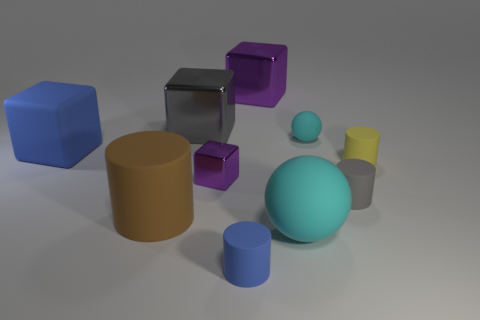There is a small gray cylinder in front of the cyan sphere that is behind the rubber cube behind the tiny purple metallic object; what is its material?
Make the answer very short. Rubber. Are there any cyan things that have the same size as the brown rubber cylinder?
Keep it short and to the point. Yes. The gray thing that is the same material as the big cyan sphere is what size?
Ensure brevity in your answer.  Small. There is a small cyan matte thing; what shape is it?
Provide a short and direct response. Sphere. Is the material of the small purple cube the same as the sphere in front of the gray rubber cylinder?
Offer a very short reply. No. What number of things are gray matte objects or purple things?
Your answer should be very brief. 3. Are there any big cylinders?
Your response must be concise. Yes. There is a purple shiny thing left of the tiny matte thing in front of the tiny gray object; what shape is it?
Your answer should be compact. Cube. How many things are purple shiny blocks that are to the left of the blue cylinder or big purple shiny cubes behind the tiny matte ball?
Provide a succinct answer. 2. There is a yellow cylinder that is the same size as the blue cylinder; what material is it?
Offer a very short reply. Rubber. 